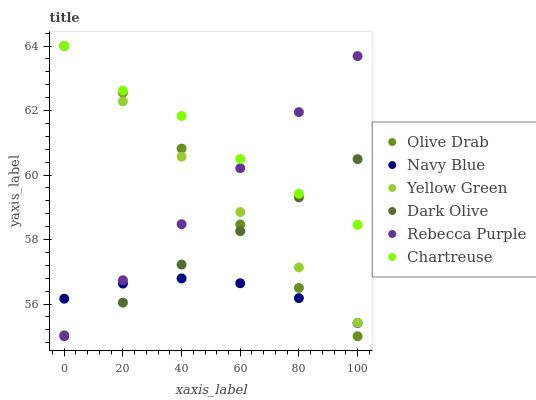Does Navy Blue have the minimum area under the curve?
Answer yes or no. Yes. Does Chartreuse have the maximum area under the curve?
Answer yes or no. Yes. Does Dark Olive have the minimum area under the curve?
Answer yes or no. No. Does Dark Olive have the maximum area under the curve?
Answer yes or no. No. Is Rebecca Purple the smoothest?
Answer yes or no. Yes. Is Olive Drab the roughest?
Answer yes or no. Yes. Is Navy Blue the smoothest?
Answer yes or no. No. Is Navy Blue the roughest?
Answer yes or no. No. Does Rebecca Purple have the lowest value?
Answer yes or no. Yes. Does Navy Blue have the lowest value?
Answer yes or no. No. Does Olive Drab have the highest value?
Answer yes or no. Yes. Does Dark Olive have the highest value?
Answer yes or no. No. Is Navy Blue less than Chartreuse?
Answer yes or no. Yes. Is Yellow Green greater than Navy Blue?
Answer yes or no. Yes. Does Dark Olive intersect Rebecca Purple?
Answer yes or no. Yes. Is Dark Olive less than Rebecca Purple?
Answer yes or no. No. Is Dark Olive greater than Rebecca Purple?
Answer yes or no. No. Does Navy Blue intersect Chartreuse?
Answer yes or no. No. 